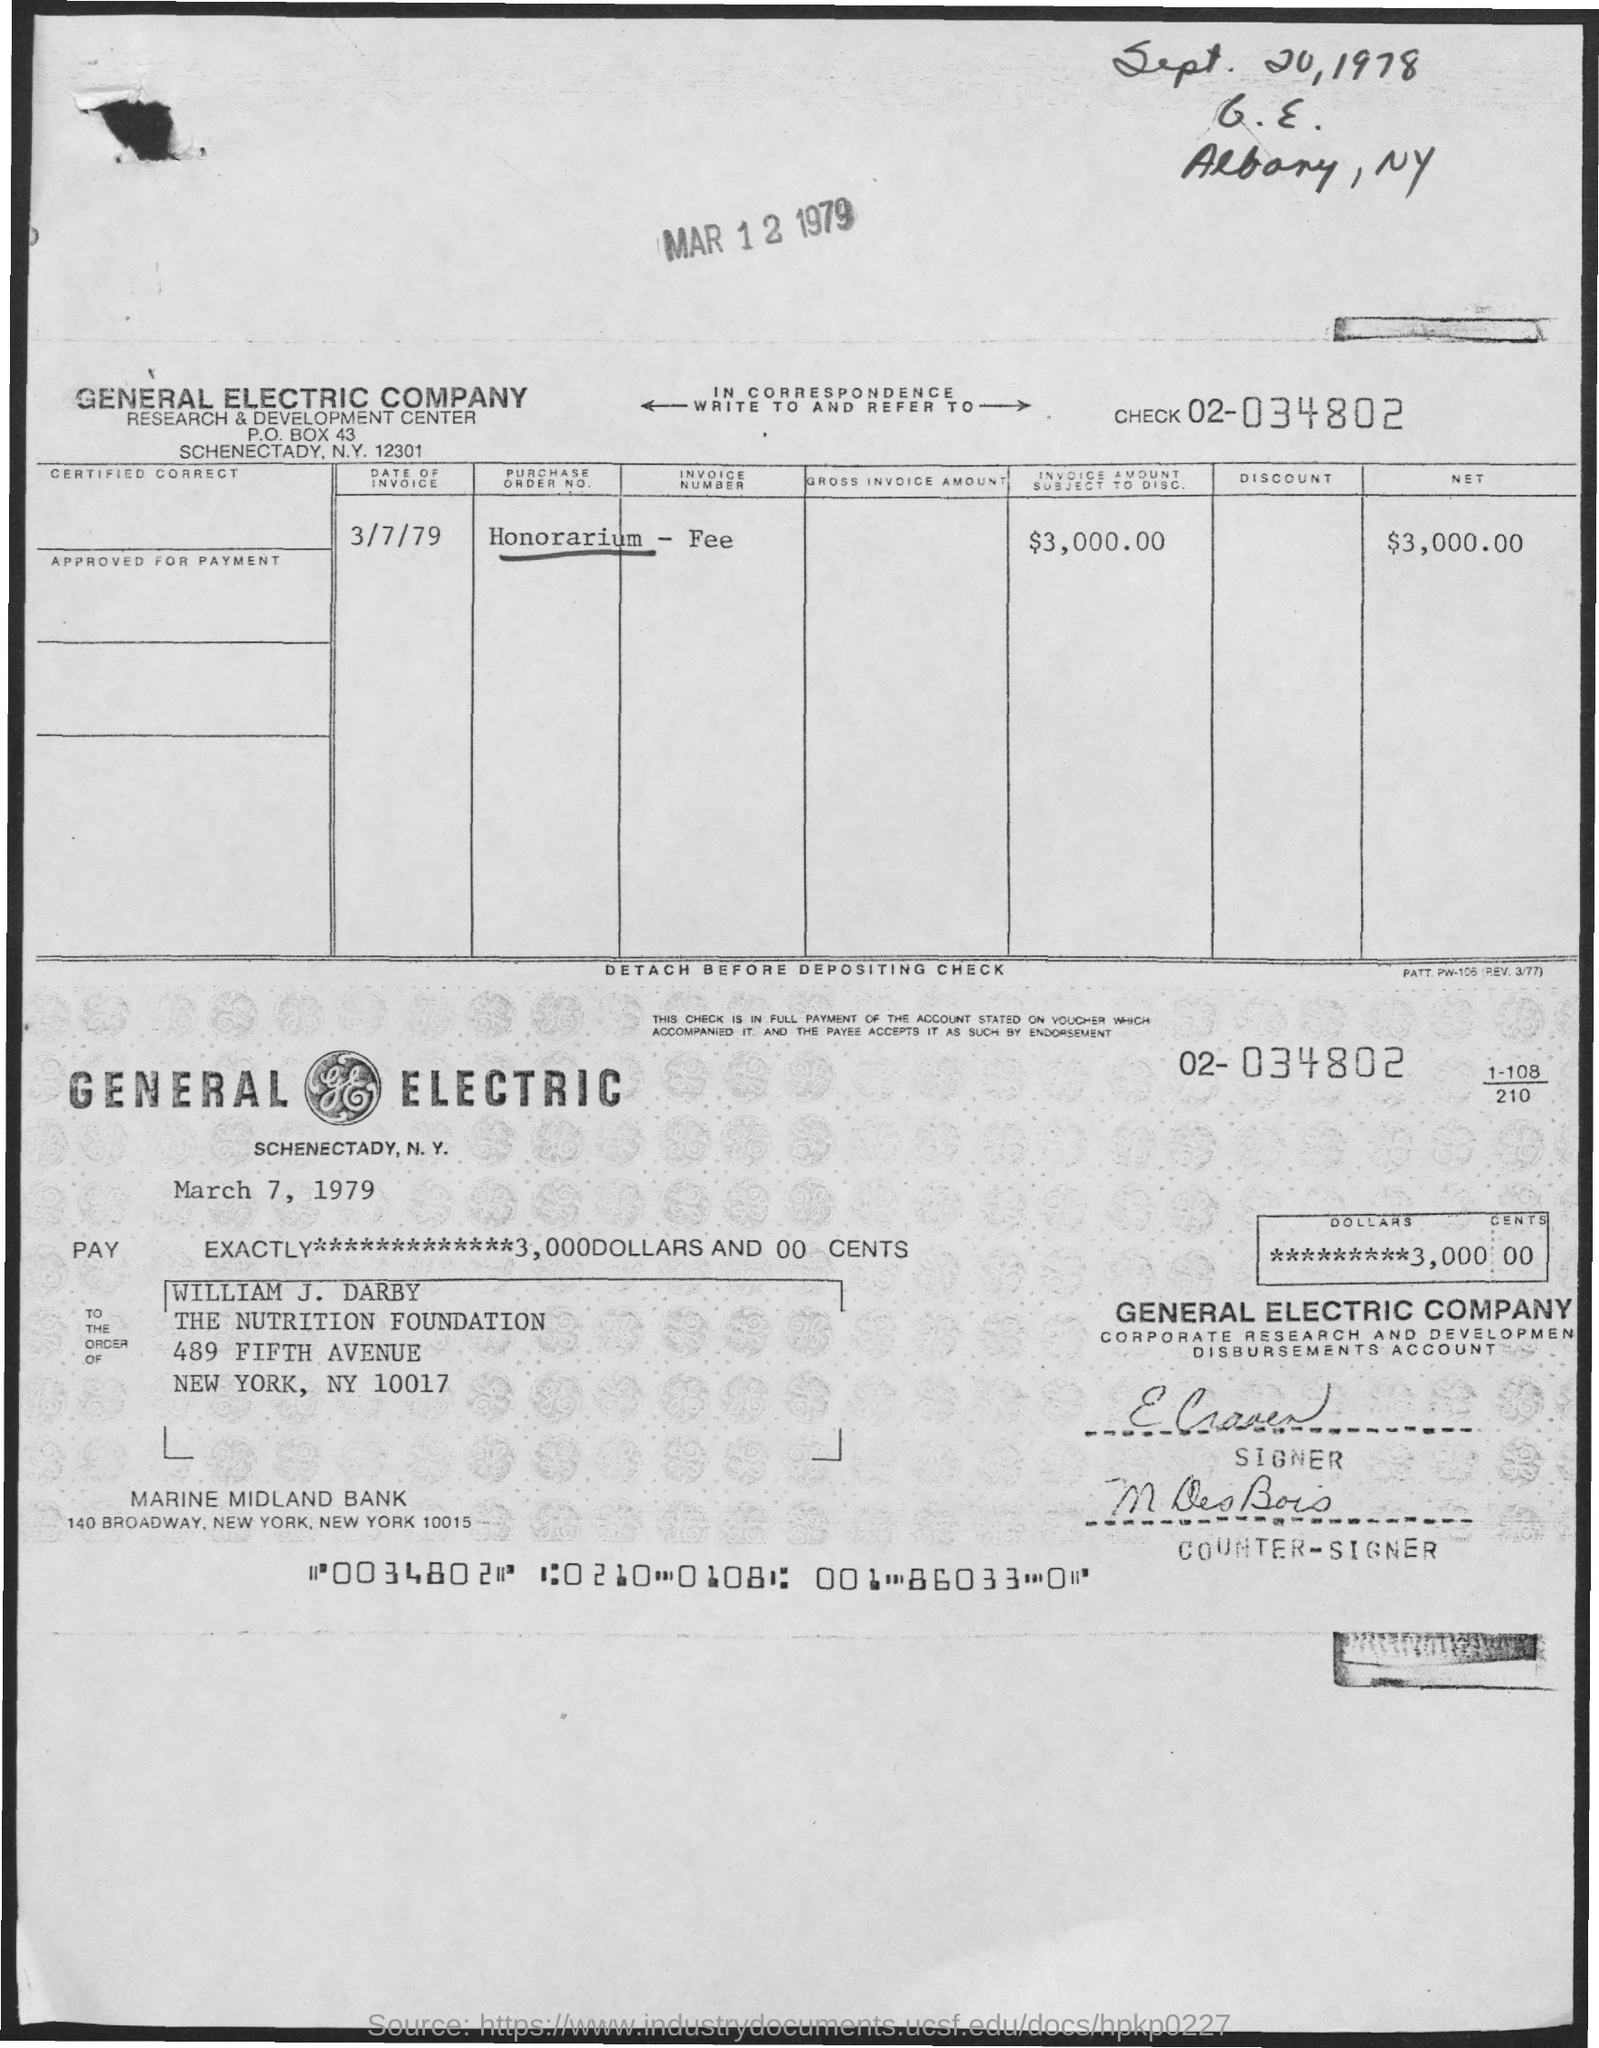Draw attention to some important aspects in this diagram. The date on the invoice is March 7, 1979. The net amount is $3,000.00. 